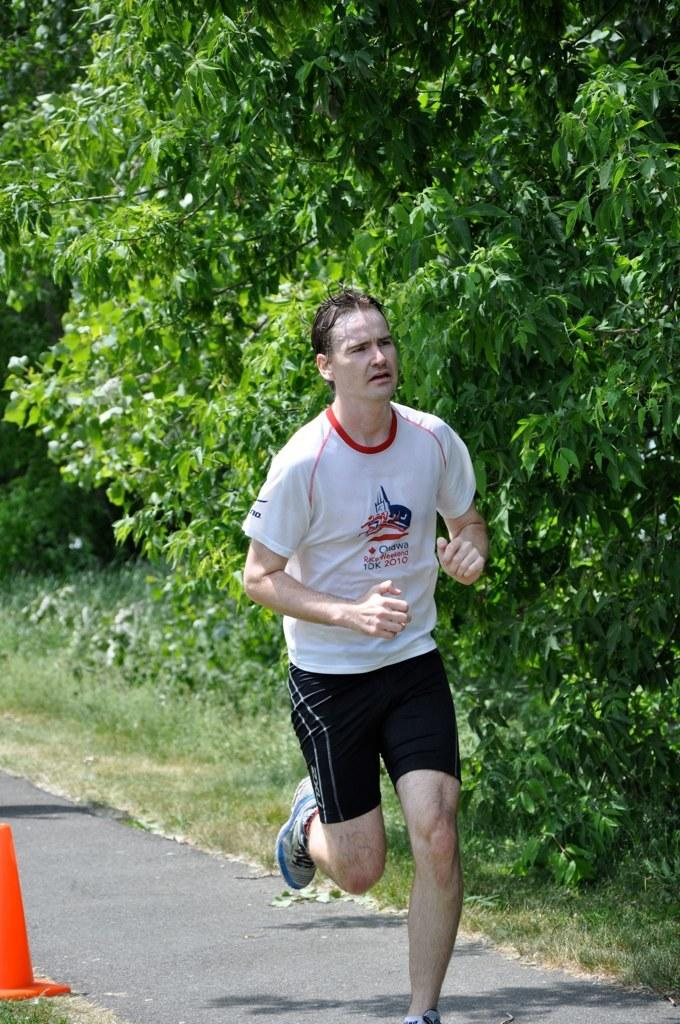What is the man in the image doing? The man is running on the road. What can be seen on the left side of the image? There is a cone on the left side of the image. What is visible in the background of the image? There are trees, plants, and grass in the background of the image. What type of pan is being used by the secretary in the image? There is no secretary or pan present in the image. Are there any fairies visible in the image? There are no fairies present in the image. 